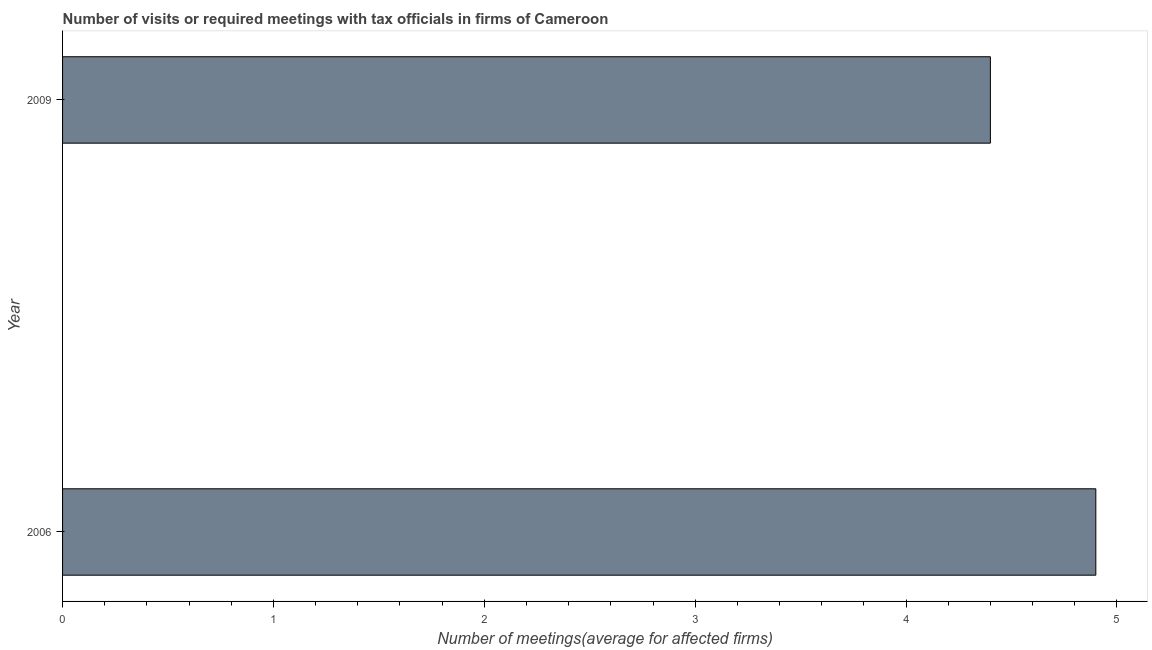Does the graph contain any zero values?
Your answer should be compact. No. Does the graph contain grids?
Provide a short and direct response. No. What is the title of the graph?
Give a very brief answer. Number of visits or required meetings with tax officials in firms of Cameroon. What is the label or title of the X-axis?
Your answer should be very brief. Number of meetings(average for affected firms). Across all years, what is the minimum number of required meetings with tax officials?
Provide a short and direct response. 4.4. In which year was the number of required meetings with tax officials maximum?
Provide a succinct answer. 2006. What is the sum of the number of required meetings with tax officials?
Ensure brevity in your answer.  9.3. What is the average number of required meetings with tax officials per year?
Offer a very short reply. 4.65. What is the median number of required meetings with tax officials?
Give a very brief answer. 4.65. In how many years, is the number of required meetings with tax officials greater than 0.2 ?
Give a very brief answer. 2. Do a majority of the years between 2009 and 2006 (inclusive) have number of required meetings with tax officials greater than 2.8 ?
Offer a terse response. No. What is the ratio of the number of required meetings with tax officials in 2006 to that in 2009?
Offer a very short reply. 1.11. Is the number of required meetings with tax officials in 2006 less than that in 2009?
Make the answer very short. No. What is the ratio of the Number of meetings(average for affected firms) in 2006 to that in 2009?
Your answer should be very brief. 1.11. 